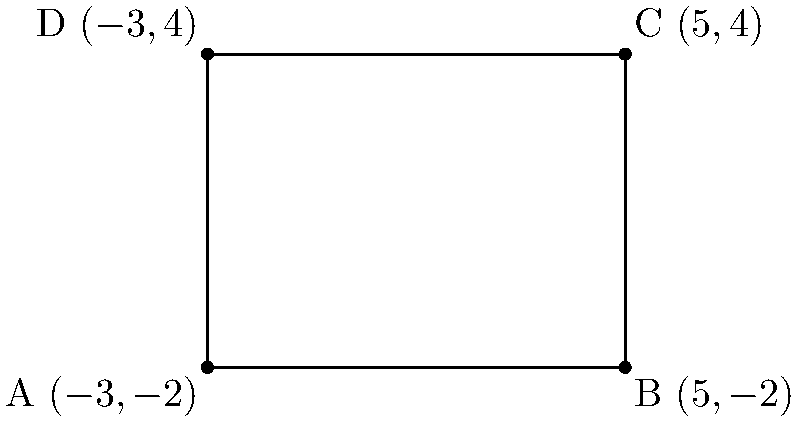In a new state-of-the-art cinema, you're designing a rectangular movie screen. The corners of the screen are represented by the following coordinates: A $(-3,-2)$, B $(5,-2)$, C $(5,4)$, and D $(-3,4)$. Calculate the area of this movie screen in square units. To find the area of the rectangular movie screen, we need to calculate its length and width:

1. Calculate the width (horizontal distance):
   Width = $x_B - x_A = 5 - (-3) = 8$ units

2. Calculate the height (vertical distance):
   Height = $y_C - y_B = 4 - (-2) = 6$ units

3. Calculate the area using the formula: Area = width $\times$ height
   Area = $8 \times 6 = 48$ square units

Therefore, the area of the movie screen is 48 square units.
Answer: 48 square units 